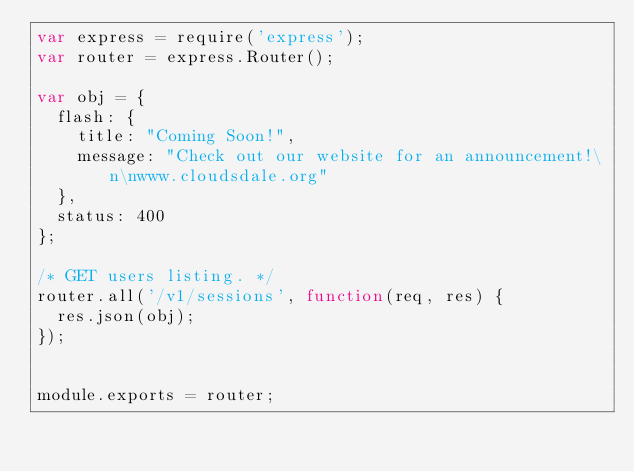Convert code to text. <code><loc_0><loc_0><loc_500><loc_500><_JavaScript_>var express = require('express');
var router = express.Router();

var obj = {
  flash: {
    title: "Coming Soon!",
    message: "Check out our website for an announcement!\n\nwww.cloudsdale.org"
  },
  status: 400
};

/* GET users listing. */
router.all('/v1/sessions', function(req, res) {
  res.json(obj);
});


module.exports = router;
</code> 